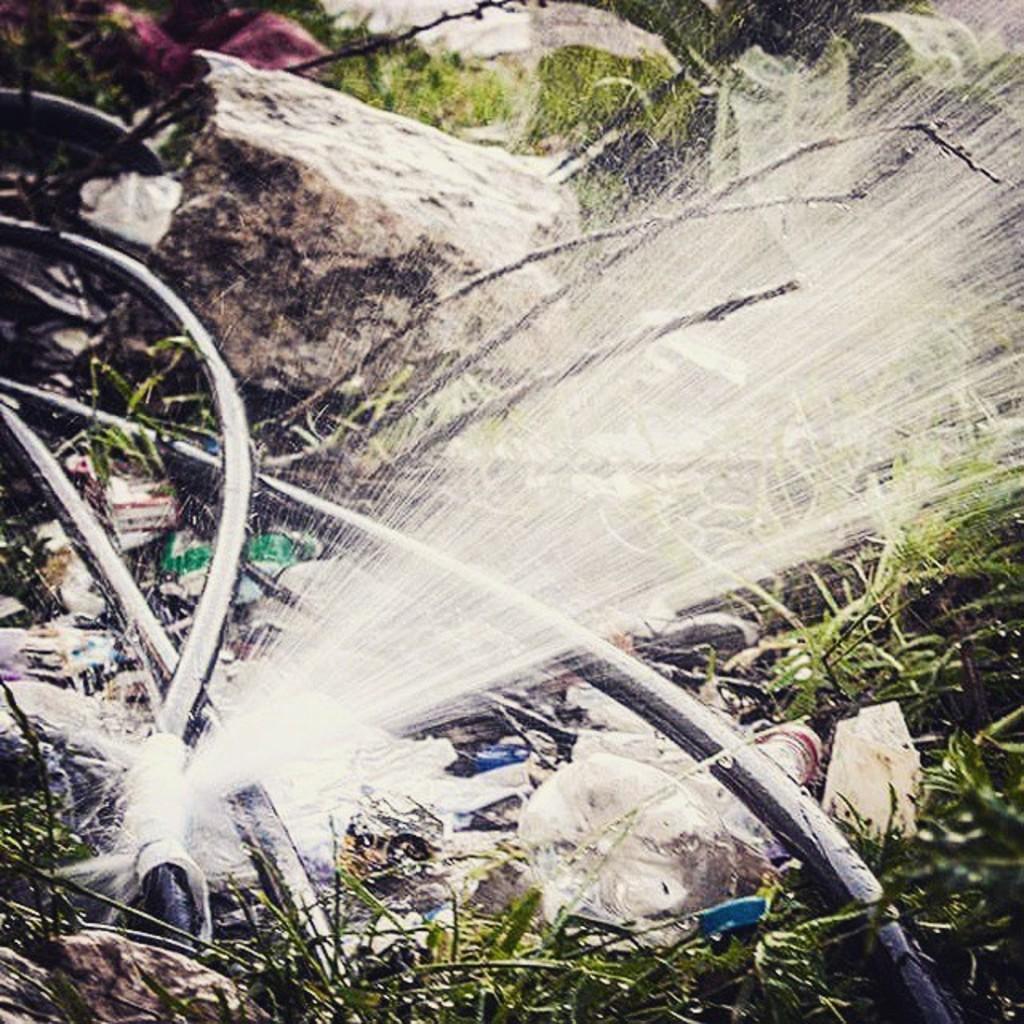How would you summarize this image in a sentence or two? In this image we can see pipes. And one pipe is broken and water is leaking from that. Also there are plants and few items. In the back there is a stone. And it is looking blur. 